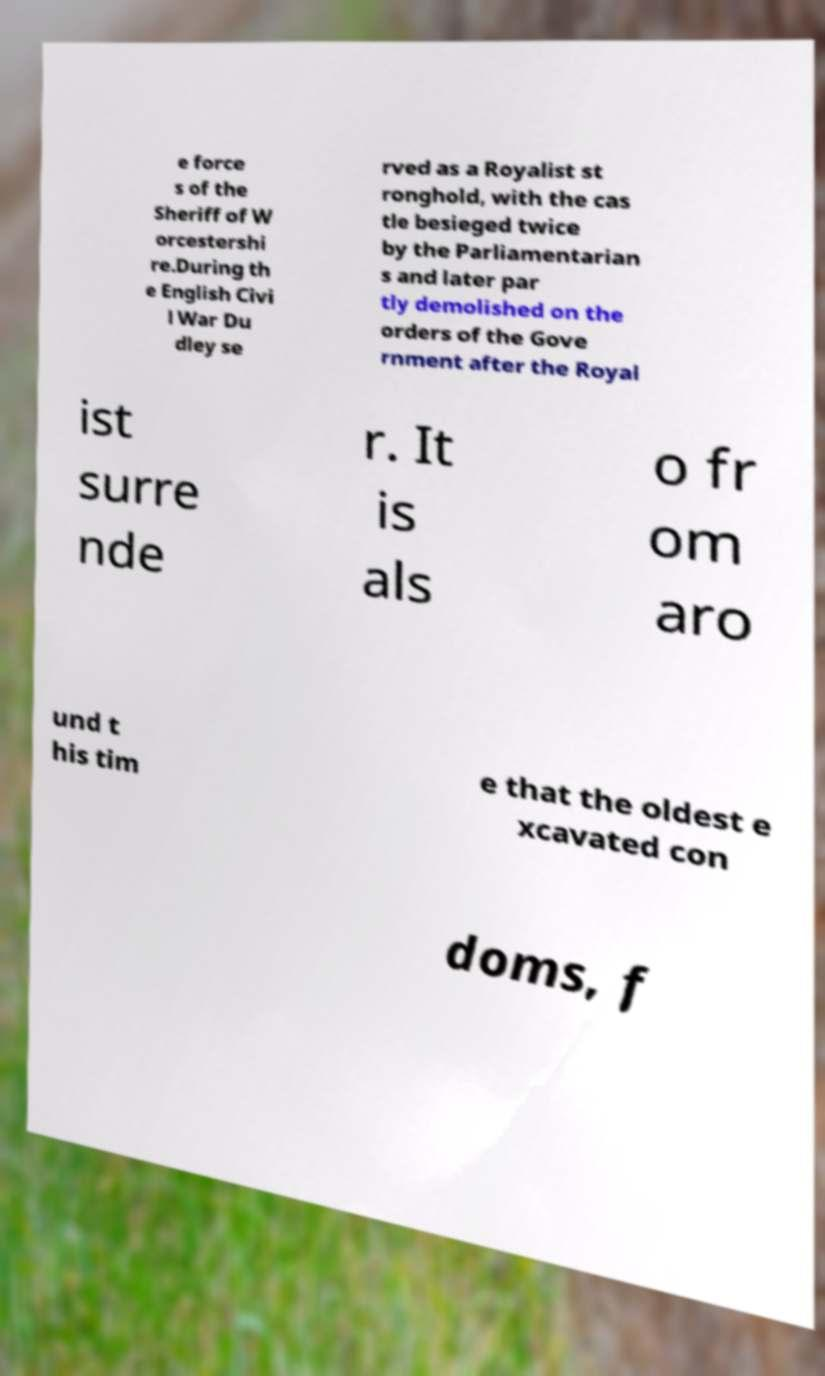Could you assist in decoding the text presented in this image and type it out clearly? e force s of the Sheriff of W orcestershi re.During th e English Civi l War Du dley se rved as a Royalist st ronghold, with the cas tle besieged twice by the Parliamentarian s and later par tly demolished on the orders of the Gove rnment after the Royal ist surre nde r. It is als o fr om aro und t his tim e that the oldest e xcavated con doms, f 